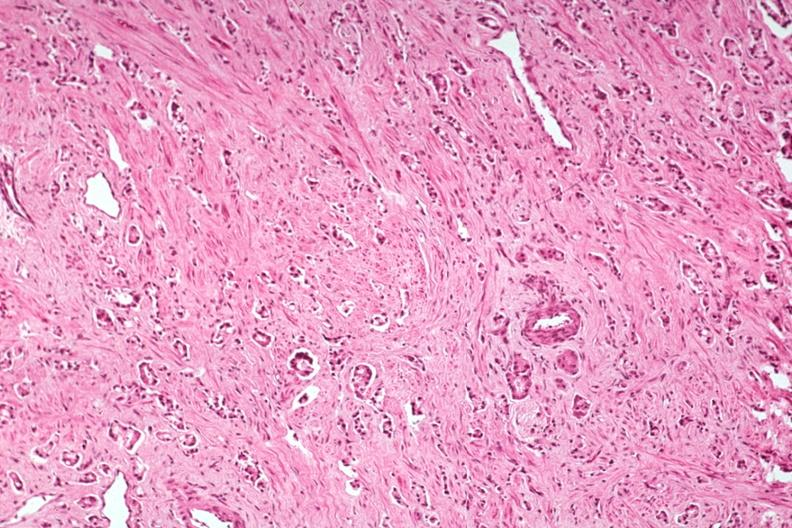what does this image show?
Answer the question using a single word or phrase. Med typical prostate cancer good example 